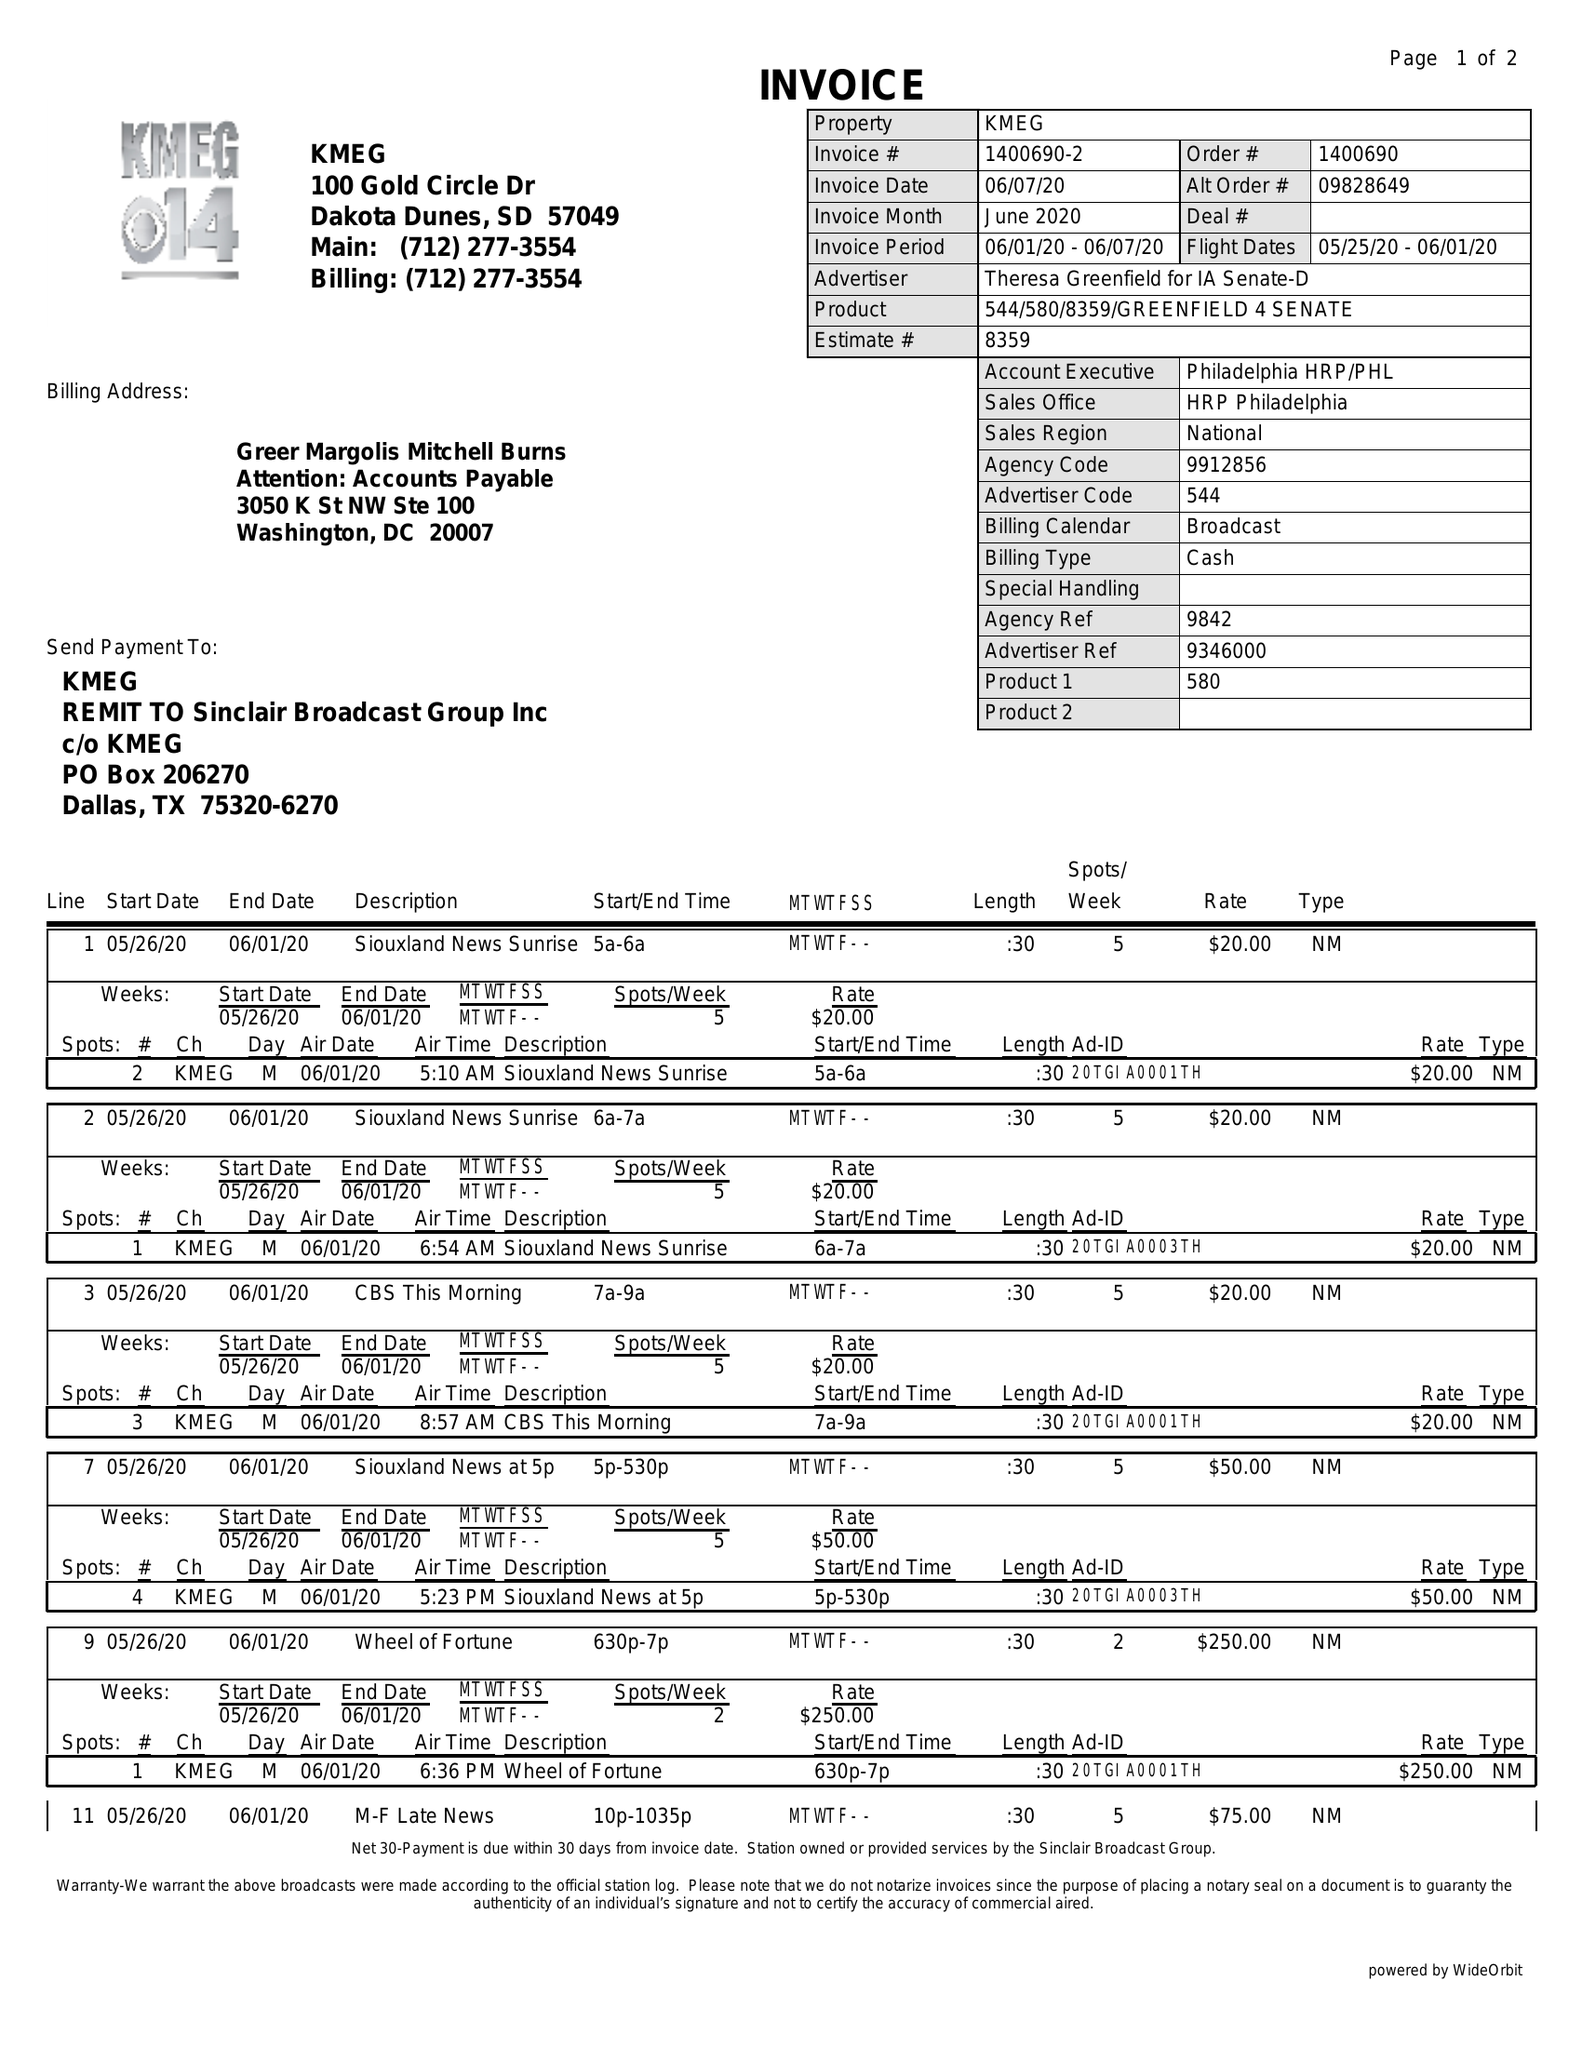What is the value for the advertiser?
Answer the question using a single word or phrase. THERESA GREENFIELD FOR IA SENATE-D 